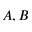Convert formula to latex. <formula><loc_0><loc_0><loc_500><loc_500>A , B</formula> 